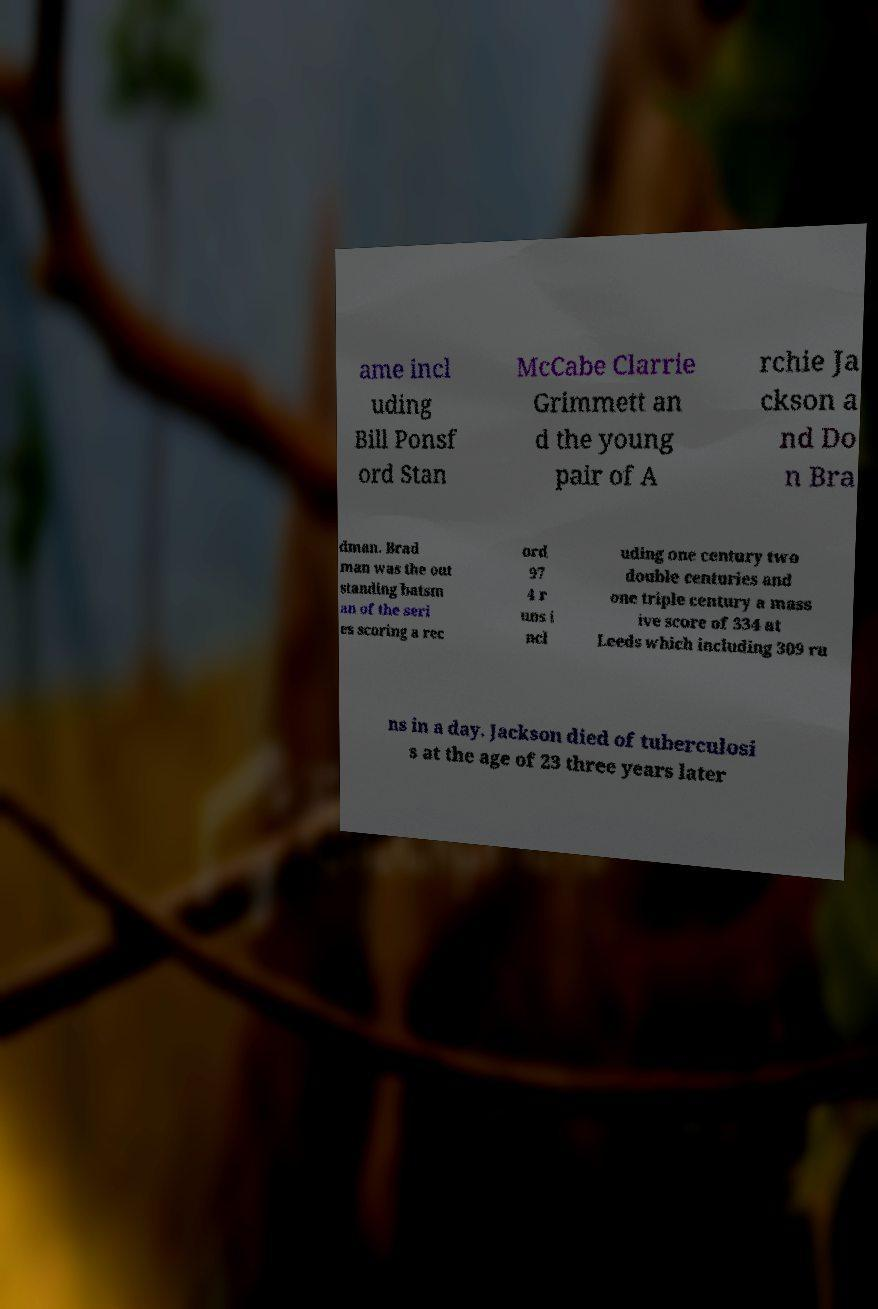Can you accurately transcribe the text from the provided image for me? ame incl uding Bill Ponsf ord Stan McCabe Clarrie Grimmett an d the young pair of A rchie Ja ckson a nd Do n Bra dman. Brad man was the out standing batsm an of the seri es scoring a rec ord 97 4 r uns i ncl uding one century two double centuries and one triple century a mass ive score of 334 at Leeds which including 309 ru ns in a day. Jackson died of tuberculosi s at the age of 23 three years later 